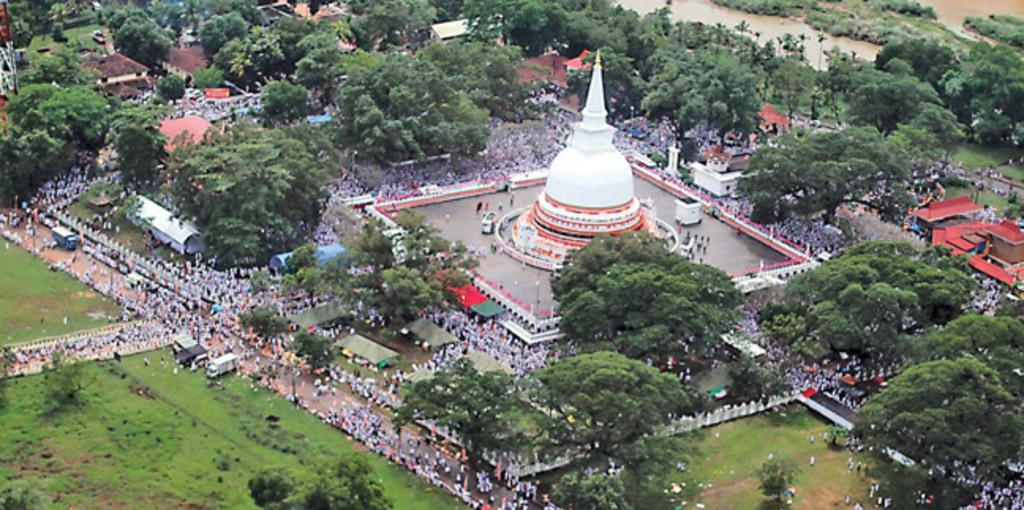What type of natural elements can be seen in the image? There are trees in the image. What type of man-made structures are present in the image? There are buildings in the image. What type of open spaces can be seen in the image? There are fields in the image. What type of transportation is visible in the image? There are vehicles in the image. What type of objects can be seen in the image? Various objects are present in the image. Where are the people located in the image? The people are in the center of the image. What are the people doing in the image? The people are gathered around a building. What type of chin can be seen on the parent in the image? There is no parent or chin present in the image. How does the breath of the people affect the design of the building in the image? There is no mention of the people's breath affecting the design of the building in the image. 